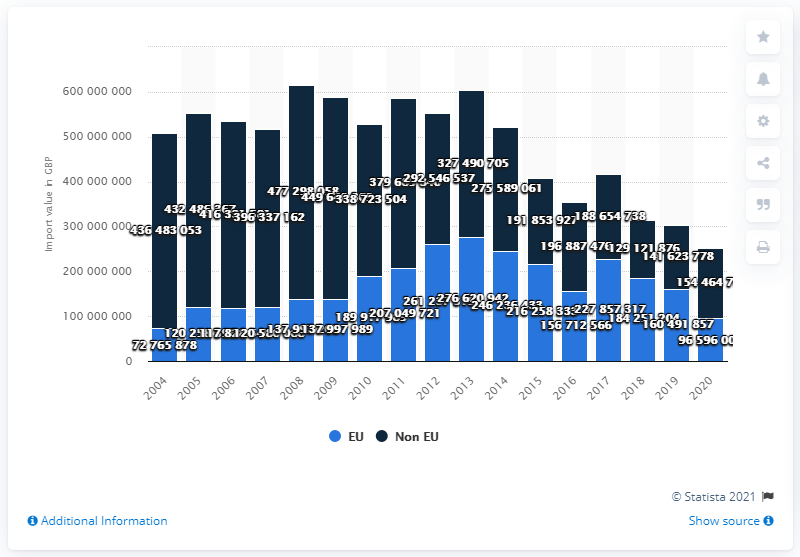Give some essential details in this illustration. In 2020, 15,446,470.5 kilograms of cane or beet sugar were imported into the United Kingdom. 